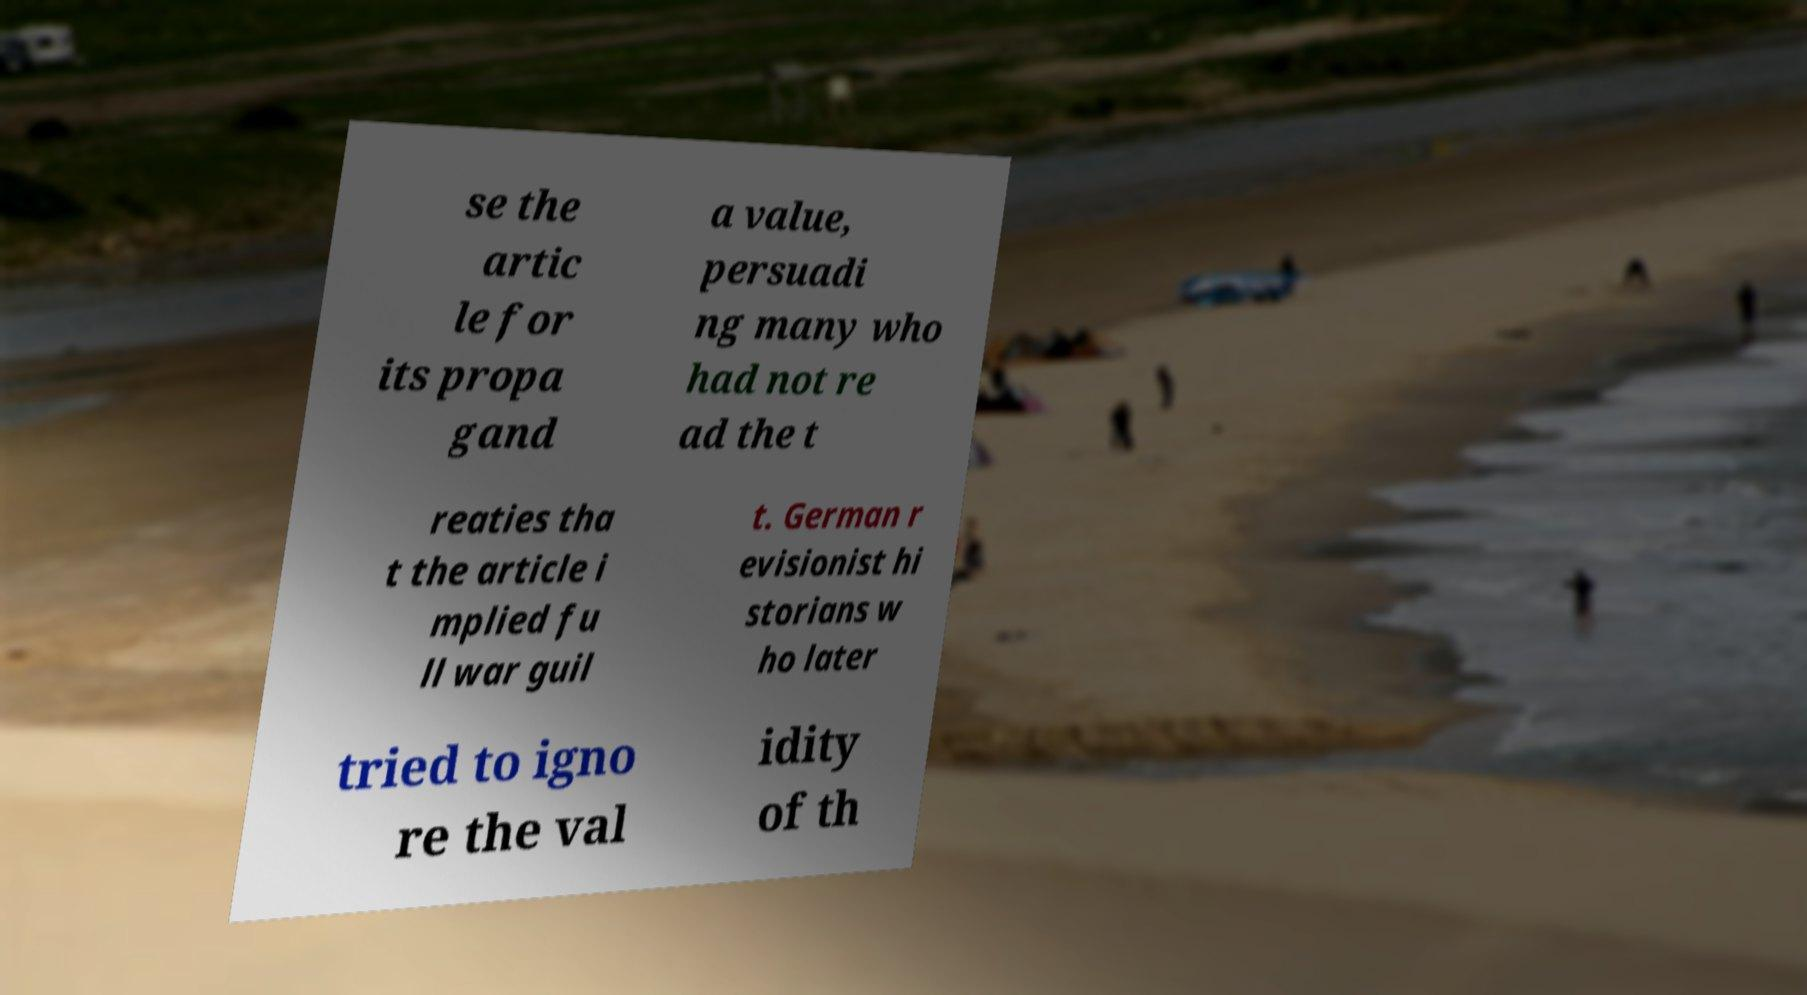Can you accurately transcribe the text from the provided image for me? se the artic le for its propa gand a value, persuadi ng many who had not re ad the t reaties tha t the article i mplied fu ll war guil t. German r evisionist hi storians w ho later tried to igno re the val idity of th 